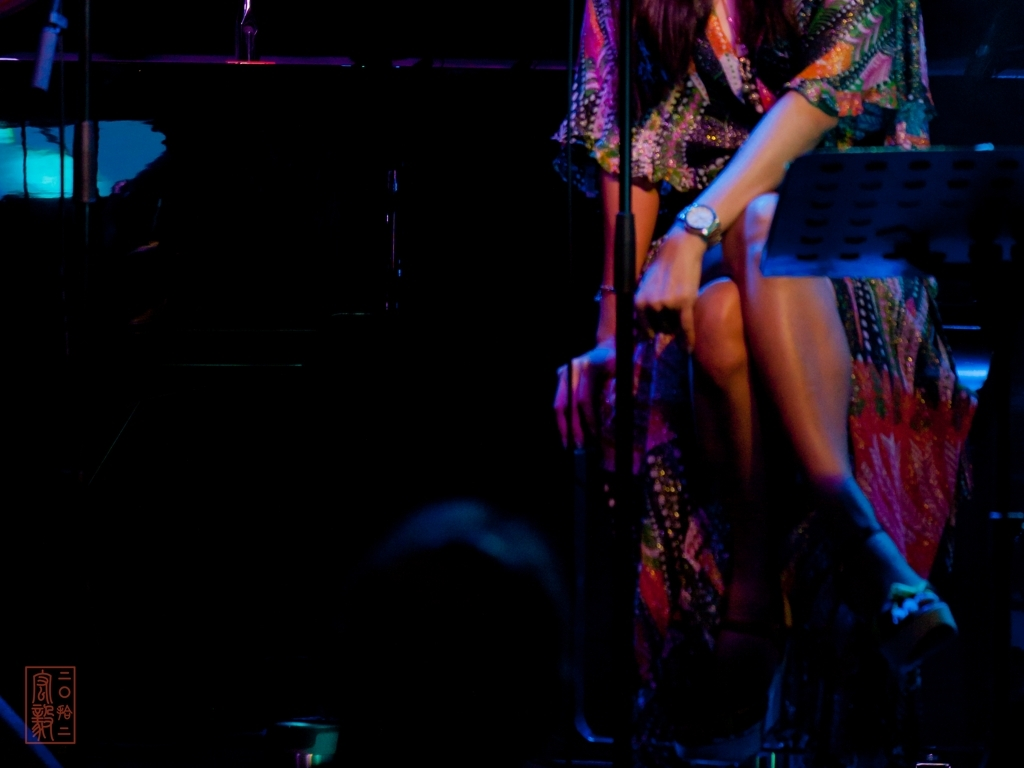Does the image suggest a particular type of event? What visual clues support your answer? The visual clues in the image, such as the microphone stand, the music stand, and the spotlighted individual, all point towards a musical or spoken word event. The manner of dress and seated posture of the person suggest an event that is curated and possibly more formal than a casual gathering. The low lighting and focus on the performer indicate that the audience’s engagement is likely directed at a live performance. 